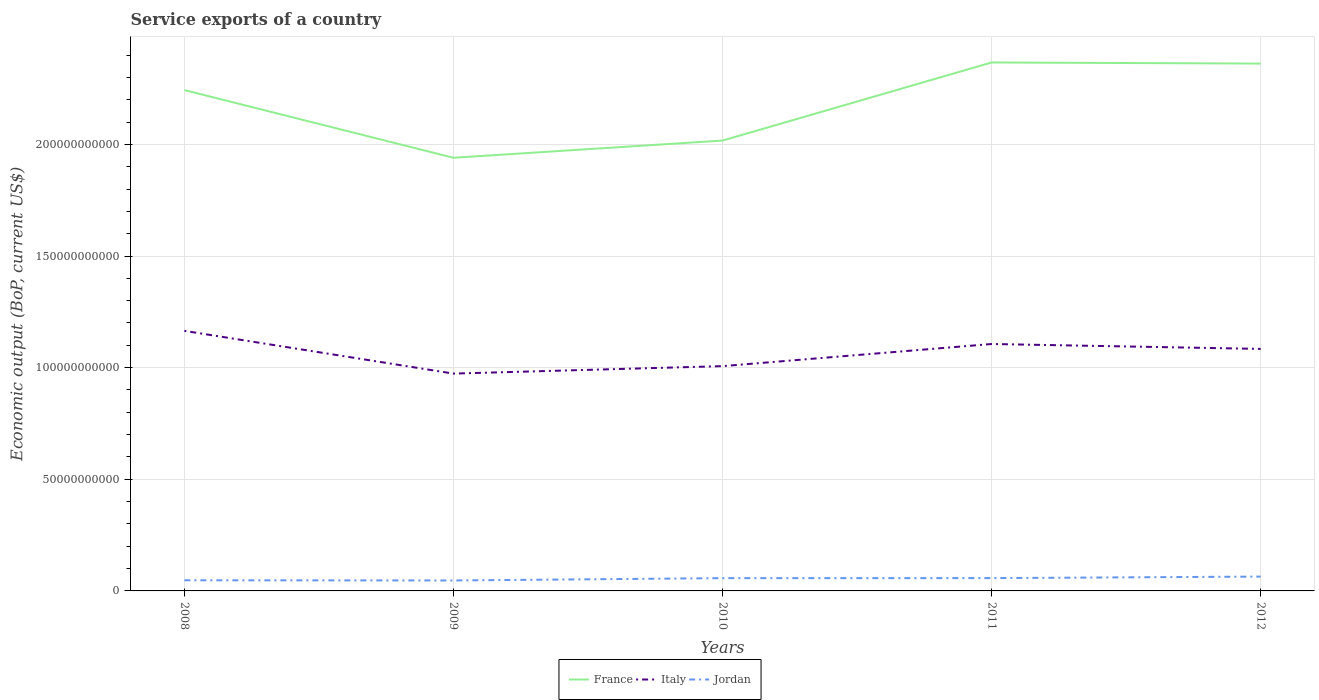Is the number of lines equal to the number of legend labels?
Provide a succinct answer. Yes. Across all years, what is the maximum service exports in France?
Offer a very short reply. 1.94e+11. In which year was the service exports in Jordan maximum?
Offer a very short reply. 2009. What is the total service exports in Jordan in the graph?
Provide a succinct answer. -9.62e+08. What is the difference between the highest and the second highest service exports in Jordan?
Ensure brevity in your answer.  1.73e+09. Is the service exports in Jordan strictly greater than the service exports in France over the years?
Ensure brevity in your answer.  Yes. How many years are there in the graph?
Offer a very short reply. 5. What is the difference between two consecutive major ticks on the Y-axis?
Give a very brief answer. 5.00e+1. Are the values on the major ticks of Y-axis written in scientific E-notation?
Your answer should be very brief. No. Does the graph contain any zero values?
Offer a terse response. No. Does the graph contain grids?
Your response must be concise. Yes. Where does the legend appear in the graph?
Your answer should be compact. Bottom center. How are the legend labels stacked?
Offer a terse response. Horizontal. What is the title of the graph?
Your response must be concise. Service exports of a country. Does "Mauritius" appear as one of the legend labels in the graph?
Offer a terse response. No. What is the label or title of the Y-axis?
Your answer should be very brief. Economic output (BoP, current US$). What is the Economic output (BoP, current US$) in France in 2008?
Make the answer very short. 2.24e+11. What is the Economic output (BoP, current US$) of Italy in 2008?
Your answer should be compact. 1.16e+11. What is the Economic output (BoP, current US$) of Jordan in 2008?
Your answer should be very brief. 4.76e+09. What is the Economic output (BoP, current US$) in France in 2009?
Provide a short and direct response. 1.94e+11. What is the Economic output (BoP, current US$) of Italy in 2009?
Ensure brevity in your answer.  9.73e+1. What is the Economic output (BoP, current US$) of Jordan in 2009?
Provide a short and direct response. 4.69e+09. What is the Economic output (BoP, current US$) of France in 2010?
Your answer should be very brief. 2.02e+11. What is the Economic output (BoP, current US$) in Italy in 2010?
Your answer should be compact. 1.01e+11. What is the Economic output (BoP, current US$) of Jordan in 2010?
Provide a succinct answer. 5.72e+09. What is the Economic output (BoP, current US$) of France in 2011?
Your response must be concise. 2.37e+11. What is the Economic output (BoP, current US$) in Italy in 2011?
Offer a terse response. 1.11e+11. What is the Economic output (BoP, current US$) of Jordan in 2011?
Provide a short and direct response. 5.74e+09. What is the Economic output (BoP, current US$) of France in 2012?
Your response must be concise. 2.36e+11. What is the Economic output (BoP, current US$) of Italy in 2012?
Your answer should be very brief. 1.08e+11. What is the Economic output (BoP, current US$) in Jordan in 2012?
Your response must be concise. 6.42e+09. Across all years, what is the maximum Economic output (BoP, current US$) of France?
Keep it short and to the point. 2.37e+11. Across all years, what is the maximum Economic output (BoP, current US$) in Italy?
Offer a terse response. 1.16e+11. Across all years, what is the maximum Economic output (BoP, current US$) in Jordan?
Give a very brief answer. 6.42e+09. Across all years, what is the minimum Economic output (BoP, current US$) in France?
Keep it short and to the point. 1.94e+11. Across all years, what is the minimum Economic output (BoP, current US$) in Italy?
Ensure brevity in your answer.  9.73e+1. Across all years, what is the minimum Economic output (BoP, current US$) of Jordan?
Your response must be concise. 4.69e+09. What is the total Economic output (BoP, current US$) in France in the graph?
Your answer should be compact. 1.09e+12. What is the total Economic output (BoP, current US$) in Italy in the graph?
Ensure brevity in your answer.  5.33e+11. What is the total Economic output (BoP, current US$) of Jordan in the graph?
Make the answer very short. 2.73e+1. What is the difference between the Economic output (BoP, current US$) in France in 2008 and that in 2009?
Your response must be concise. 3.03e+1. What is the difference between the Economic output (BoP, current US$) of Italy in 2008 and that in 2009?
Give a very brief answer. 1.91e+1. What is the difference between the Economic output (BoP, current US$) in Jordan in 2008 and that in 2009?
Your answer should be compact. 7.58e+07. What is the difference between the Economic output (BoP, current US$) of France in 2008 and that in 2010?
Offer a terse response. 2.26e+1. What is the difference between the Economic output (BoP, current US$) in Italy in 2008 and that in 2010?
Provide a short and direct response. 1.58e+1. What is the difference between the Economic output (BoP, current US$) in Jordan in 2008 and that in 2010?
Your answer should be compact. -9.62e+08. What is the difference between the Economic output (BoP, current US$) of France in 2008 and that in 2011?
Your response must be concise. -1.24e+1. What is the difference between the Economic output (BoP, current US$) in Italy in 2008 and that in 2011?
Offer a terse response. 5.89e+09. What is the difference between the Economic output (BoP, current US$) of Jordan in 2008 and that in 2011?
Offer a very short reply. -9.76e+08. What is the difference between the Economic output (BoP, current US$) in France in 2008 and that in 2012?
Provide a short and direct response. -1.19e+1. What is the difference between the Economic output (BoP, current US$) of Italy in 2008 and that in 2012?
Your answer should be very brief. 8.09e+09. What is the difference between the Economic output (BoP, current US$) in Jordan in 2008 and that in 2012?
Make the answer very short. -1.66e+09. What is the difference between the Economic output (BoP, current US$) in France in 2009 and that in 2010?
Your answer should be very brief. -7.70e+09. What is the difference between the Economic output (BoP, current US$) in Italy in 2009 and that in 2010?
Your answer should be very brief. -3.34e+09. What is the difference between the Economic output (BoP, current US$) of Jordan in 2009 and that in 2010?
Your answer should be very brief. -1.04e+09. What is the difference between the Economic output (BoP, current US$) of France in 2009 and that in 2011?
Ensure brevity in your answer.  -4.27e+1. What is the difference between the Economic output (BoP, current US$) in Italy in 2009 and that in 2011?
Make the answer very short. -1.33e+1. What is the difference between the Economic output (BoP, current US$) of Jordan in 2009 and that in 2011?
Your response must be concise. -1.05e+09. What is the difference between the Economic output (BoP, current US$) in France in 2009 and that in 2012?
Provide a succinct answer. -4.22e+1. What is the difference between the Economic output (BoP, current US$) of Italy in 2009 and that in 2012?
Your response must be concise. -1.11e+1. What is the difference between the Economic output (BoP, current US$) of Jordan in 2009 and that in 2012?
Provide a short and direct response. -1.73e+09. What is the difference between the Economic output (BoP, current US$) in France in 2010 and that in 2011?
Ensure brevity in your answer.  -3.50e+1. What is the difference between the Economic output (BoP, current US$) of Italy in 2010 and that in 2011?
Provide a succinct answer. -9.91e+09. What is the difference between the Economic output (BoP, current US$) in Jordan in 2010 and that in 2011?
Your response must be concise. -1.39e+07. What is the difference between the Economic output (BoP, current US$) in France in 2010 and that in 2012?
Offer a very short reply. -3.45e+1. What is the difference between the Economic output (BoP, current US$) in Italy in 2010 and that in 2012?
Make the answer very short. -7.71e+09. What is the difference between the Economic output (BoP, current US$) of Jordan in 2010 and that in 2012?
Your answer should be compact. -6.97e+08. What is the difference between the Economic output (BoP, current US$) of France in 2011 and that in 2012?
Your answer should be very brief. 4.93e+08. What is the difference between the Economic output (BoP, current US$) of Italy in 2011 and that in 2012?
Give a very brief answer. 2.20e+09. What is the difference between the Economic output (BoP, current US$) in Jordan in 2011 and that in 2012?
Offer a terse response. -6.83e+08. What is the difference between the Economic output (BoP, current US$) in France in 2008 and the Economic output (BoP, current US$) in Italy in 2009?
Your answer should be compact. 1.27e+11. What is the difference between the Economic output (BoP, current US$) in France in 2008 and the Economic output (BoP, current US$) in Jordan in 2009?
Your answer should be very brief. 2.20e+11. What is the difference between the Economic output (BoP, current US$) of Italy in 2008 and the Economic output (BoP, current US$) of Jordan in 2009?
Your response must be concise. 1.12e+11. What is the difference between the Economic output (BoP, current US$) in France in 2008 and the Economic output (BoP, current US$) in Italy in 2010?
Offer a very short reply. 1.24e+11. What is the difference between the Economic output (BoP, current US$) of France in 2008 and the Economic output (BoP, current US$) of Jordan in 2010?
Ensure brevity in your answer.  2.19e+11. What is the difference between the Economic output (BoP, current US$) of Italy in 2008 and the Economic output (BoP, current US$) of Jordan in 2010?
Your answer should be very brief. 1.11e+11. What is the difference between the Economic output (BoP, current US$) of France in 2008 and the Economic output (BoP, current US$) of Italy in 2011?
Your answer should be very brief. 1.14e+11. What is the difference between the Economic output (BoP, current US$) of France in 2008 and the Economic output (BoP, current US$) of Jordan in 2011?
Ensure brevity in your answer.  2.19e+11. What is the difference between the Economic output (BoP, current US$) of Italy in 2008 and the Economic output (BoP, current US$) of Jordan in 2011?
Ensure brevity in your answer.  1.11e+11. What is the difference between the Economic output (BoP, current US$) of France in 2008 and the Economic output (BoP, current US$) of Italy in 2012?
Offer a very short reply. 1.16e+11. What is the difference between the Economic output (BoP, current US$) in France in 2008 and the Economic output (BoP, current US$) in Jordan in 2012?
Your response must be concise. 2.18e+11. What is the difference between the Economic output (BoP, current US$) of Italy in 2008 and the Economic output (BoP, current US$) of Jordan in 2012?
Provide a short and direct response. 1.10e+11. What is the difference between the Economic output (BoP, current US$) in France in 2009 and the Economic output (BoP, current US$) in Italy in 2010?
Offer a very short reply. 9.33e+1. What is the difference between the Economic output (BoP, current US$) of France in 2009 and the Economic output (BoP, current US$) of Jordan in 2010?
Ensure brevity in your answer.  1.88e+11. What is the difference between the Economic output (BoP, current US$) of Italy in 2009 and the Economic output (BoP, current US$) of Jordan in 2010?
Your response must be concise. 9.16e+1. What is the difference between the Economic output (BoP, current US$) in France in 2009 and the Economic output (BoP, current US$) in Italy in 2011?
Keep it short and to the point. 8.34e+1. What is the difference between the Economic output (BoP, current US$) in France in 2009 and the Economic output (BoP, current US$) in Jordan in 2011?
Your response must be concise. 1.88e+11. What is the difference between the Economic output (BoP, current US$) in Italy in 2009 and the Economic output (BoP, current US$) in Jordan in 2011?
Make the answer very short. 9.16e+1. What is the difference between the Economic output (BoP, current US$) in France in 2009 and the Economic output (BoP, current US$) in Italy in 2012?
Give a very brief answer. 8.56e+1. What is the difference between the Economic output (BoP, current US$) in France in 2009 and the Economic output (BoP, current US$) in Jordan in 2012?
Provide a succinct answer. 1.88e+11. What is the difference between the Economic output (BoP, current US$) in Italy in 2009 and the Economic output (BoP, current US$) in Jordan in 2012?
Provide a succinct answer. 9.09e+1. What is the difference between the Economic output (BoP, current US$) in France in 2010 and the Economic output (BoP, current US$) in Italy in 2011?
Ensure brevity in your answer.  9.11e+1. What is the difference between the Economic output (BoP, current US$) of France in 2010 and the Economic output (BoP, current US$) of Jordan in 2011?
Provide a short and direct response. 1.96e+11. What is the difference between the Economic output (BoP, current US$) of Italy in 2010 and the Economic output (BoP, current US$) of Jordan in 2011?
Provide a succinct answer. 9.49e+1. What is the difference between the Economic output (BoP, current US$) of France in 2010 and the Economic output (BoP, current US$) of Italy in 2012?
Provide a short and direct response. 9.33e+1. What is the difference between the Economic output (BoP, current US$) in France in 2010 and the Economic output (BoP, current US$) in Jordan in 2012?
Provide a short and direct response. 1.95e+11. What is the difference between the Economic output (BoP, current US$) in Italy in 2010 and the Economic output (BoP, current US$) in Jordan in 2012?
Provide a short and direct response. 9.43e+1. What is the difference between the Economic output (BoP, current US$) of France in 2011 and the Economic output (BoP, current US$) of Italy in 2012?
Your answer should be compact. 1.28e+11. What is the difference between the Economic output (BoP, current US$) of France in 2011 and the Economic output (BoP, current US$) of Jordan in 2012?
Your response must be concise. 2.30e+11. What is the difference between the Economic output (BoP, current US$) of Italy in 2011 and the Economic output (BoP, current US$) of Jordan in 2012?
Make the answer very short. 1.04e+11. What is the average Economic output (BoP, current US$) in France per year?
Offer a very short reply. 2.19e+11. What is the average Economic output (BoP, current US$) in Italy per year?
Your response must be concise. 1.07e+11. What is the average Economic output (BoP, current US$) of Jordan per year?
Make the answer very short. 5.47e+09. In the year 2008, what is the difference between the Economic output (BoP, current US$) of France and Economic output (BoP, current US$) of Italy?
Provide a succinct answer. 1.08e+11. In the year 2008, what is the difference between the Economic output (BoP, current US$) in France and Economic output (BoP, current US$) in Jordan?
Offer a very short reply. 2.20e+11. In the year 2008, what is the difference between the Economic output (BoP, current US$) of Italy and Economic output (BoP, current US$) of Jordan?
Provide a short and direct response. 1.12e+11. In the year 2009, what is the difference between the Economic output (BoP, current US$) in France and Economic output (BoP, current US$) in Italy?
Make the answer very short. 9.67e+1. In the year 2009, what is the difference between the Economic output (BoP, current US$) in France and Economic output (BoP, current US$) in Jordan?
Offer a terse response. 1.89e+11. In the year 2009, what is the difference between the Economic output (BoP, current US$) of Italy and Economic output (BoP, current US$) of Jordan?
Your answer should be very brief. 9.26e+1. In the year 2010, what is the difference between the Economic output (BoP, current US$) of France and Economic output (BoP, current US$) of Italy?
Give a very brief answer. 1.01e+11. In the year 2010, what is the difference between the Economic output (BoP, current US$) in France and Economic output (BoP, current US$) in Jordan?
Give a very brief answer. 1.96e+11. In the year 2010, what is the difference between the Economic output (BoP, current US$) of Italy and Economic output (BoP, current US$) of Jordan?
Ensure brevity in your answer.  9.50e+1. In the year 2011, what is the difference between the Economic output (BoP, current US$) of France and Economic output (BoP, current US$) of Italy?
Keep it short and to the point. 1.26e+11. In the year 2011, what is the difference between the Economic output (BoP, current US$) in France and Economic output (BoP, current US$) in Jordan?
Your answer should be compact. 2.31e+11. In the year 2011, what is the difference between the Economic output (BoP, current US$) in Italy and Economic output (BoP, current US$) in Jordan?
Give a very brief answer. 1.05e+11. In the year 2012, what is the difference between the Economic output (BoP, current US$) of France and Economic output (BoP, current US$) of Italy?
Provide a short and direct response. 1.28e+11. In the year 2012, what is the difference between the Economic output (BoP, current US$) in France and Economic output (BoP, current US$) in Jordan?
Offer a very short reply. 2.30e+11. In the year 2012, what is the difference between the Economic output (BoP, current US$) in Italy and Economic output (BoP, current US$) in Jordan?
Offer a terse response. 1.02e+11. What is the ratio of the Economic output (BoP, current US$) in France in 2008 to that in 2009?
Give a very brief answer. 1.16. What is the ratio of the Economic output (BoP, current US$) of Italy in 2008 to that in 2009?
Ensure brevity in your answer.  1.2. What is the ratio of the Economic output (BoP, current US$) of Jordan in 2008 to that in 2009?
Offer a terse response. 1.02. What is the ratio of the Economic output (BoP, current US$) in France in 2008 to that in 2010?
Offer a terse response. 1.11. What is the ratio of the Economic output (BoP, current US$) in Italy in 2008 to that in 2010?
Your answer should be very brief. 1.16. What is the ratio of the Economic output (BoP, current US$) in Jordan in 2008 to that in 2010?
Make the answer very short. 0.83. What is the ratio of the Economic output (BoP, current US$) in France in 2008 to that in 2011?
Offer a very short reply. 0.95. What is the ratio of the Economic output (BoP, current US$) in Italy in 2008 to that in 2011?
Provide a short and direct response. 1.05. What is the ratio of the Economic output (BoP, current US$) of Jordan in 2008 to that in 2011?
Give a very brief answer. 0.83. What is the ratio of the Economic output (BoP, current US$) in France in 2008 to that in 2012?
Your answer should be very brief. 0.95. What is the ratio of the Economic output (BoP, current US$) of Italy in 2008 to that in 2012?
Provide a short and direct response. 1.07. What is the ratio of the Economic output (BoP, current US$) in Jordan in 2008 to that in 2012?
Ensure brevity in your answer.  0.74. What is the ratio of the Economic output (BoP, current US$) in France in 2009 to that in 2010?
Provide a short and direct response. 0.96. What is the ratio of the Economic output (BoP, current US$) in Italy in 2009 to that in 2010?
Provide a short and direct response. 0.97. What is the ratio of the Economic output (BoP, current US$) in Jordan in 2009 to that in 2010?
Give a very brief answer. 0.82. What is the ratio of the Economic output (BoP, current US$) of France in 2009 to that in 2011?
Your answer should be very brief. 0.82. What is the ratio of the Economic output (BoP, current US$) in Italy in 2009 to that in 2011?
Make the answer very short. 0.88. What is the ratio of the Economic output (BoP, current US$) in Jordan in 2009 to that in 2011?
Ensure brevity in your answer.  0.82. What is the ratio of the Economic output (BoP, current US$) in France in 2009 to that in 2012?
Your answer should be very brief. 0.82. What is the ratio of the Economic output (BoP, current US$) in Italy in 2009 to that in 2012?
Ensure brevity in your answer.  0.9. What is the ratio of the Economic output (BoP, current US$) of Jordan in 2009 to that in 2012?
Your answer should be compact. 0.73. What is the ratio of the Economic output (BoP, current US$) in France in 2010 to that in 2011?
Your response must be concise. 0.85. What is the ratio of the Economic output (BoP, current US$) of Italy in 2010 to that in 2011?
Your response must be concise. 0.91. What is the ratio of the Economic output (BoP, current US$) in France in 2010 to that in 2012?
Your answer should be compact. 0.85. What is the ratio of the Economic output (BoP, current US$) in Italy in 2010 to that in 2012?
Your answer should be compact. 0.93. What is the ratio of the Economic output (BoP, current US$) in Jordan in 2010 to that in 2012?
Provide a short and direct response. 0.89. What is the ratio of the Economic output (BoP, current US$) of Italy in 2011 to that in 2012?
Make the answer very short. 1.02. What is the ratio of the Economic output (BoP, current US$) in Jordan in 2011 to that in 2012?
Offer a terse response. 0.89. What is the difference between the highest and the second highest Economic output (BoP, current US$) of France?
Provide a succinct answer. 4.93e+08. What is the difference between the highest and the second highest Economic output (BoP, current US$) of Italy?
Ensure brevity in your answer.  5.89e+09. What is the difference between the highest and the second highest Economic output (BoP, current US$) of Jordan?
Your response must be concise. 6.83e+08. What is the difference between the highest and the lowest Economic output (BoP, current US$) of France?
Provide a short and direct response. 4.27e+1. What is the difference between the highest and the lowest Economic output (BoP, current US$) in Italy?
Make the answer very short. 1.91e+1. What is the difference between the highest and the lowest Economic output (BoP, current US$) of Jordan?
Provide a succinct answer. 1.73e+09. 